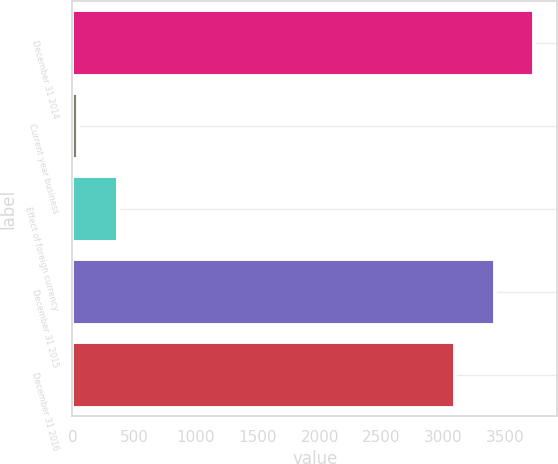Convert chart. <chart><loc_0><loc_0><loc_500><loc_500><bar_chart><fcel>December 31 2014<fcel>Current year business<fcel>Effect of foreign currency<fcel>December 31 2015<fcel>December 31 2016<nl><fcel>3737.02<fcel>45<fcel>366.71<fcel>3415.31<fcel>3093.6<nl></chart> 